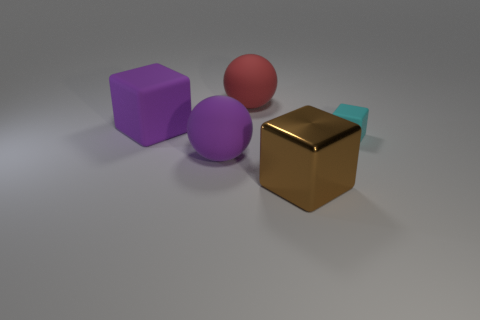Are there any other things that have the same size as the cyan block?
Offer a terse response. No. There is a big block on the right side of the large purple rubber object to the right of the large block that is on the left side of the red thing; what color is it?
Offer a very short reply. Brown. Are there any other rubber things that have the same shape as the tiny cyan matte object?
Your answer should be very brief. Yes. Are there an equal number of purple rubber spheres on the right side of the brown metal object and large purple objects behind the purple rubber cube?
Provide a succinct answer. Yes. There is a small cyan object that is on the right side of the big red sphere; does it have the same shape as the big metallic thing?
Keep it short and to the point. Yes. Does the brown object have the same shape as the cyan thing?
Your response must be concise. Yes. What number of rubber things are either purple blocks or tiny green blocks?
Your response must be concise. 1. Do the red matte object and the shiny object have the same size?
Offer a very short reply. Yes. What number of things are either brown things or matte things behind the purple block?
Ensure brevity in your answer.  2. There is a brown thing that is the same size as the purple ball; what material is it?
Your response must be concise. Metal. 